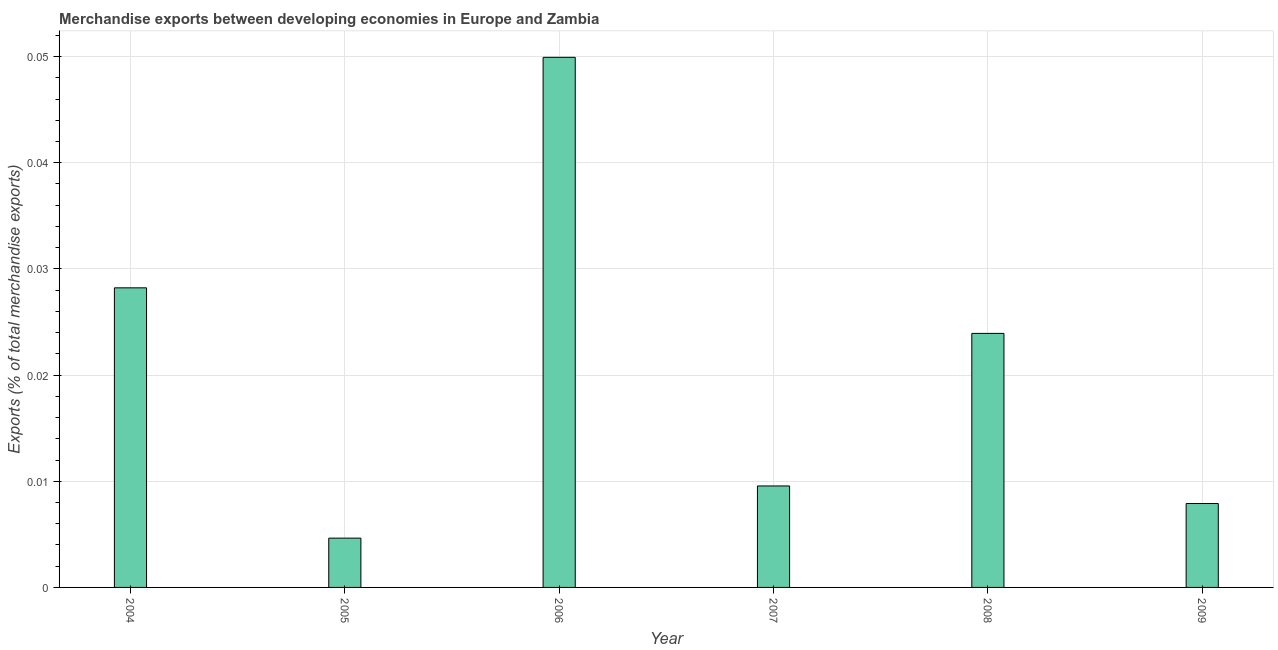Does the graph contain any zero values?
Give a very brief answer. No. Does the graph contain grids?
Ensure brevity in your answer.  Yes. What is the title of the graph?
Make the answer very short. Merchandise exports between developing economies in Europe and Zambia. What is the label or title of the X-axis?
Make the answer very short. Year. What is the label or title of the Y-axis?
Offer a very short reply. Exports (% of total merchandise exports). What is the merchandise exports in 2006?
Offer a terse response. 0.05. Across all years, what is the maximum merchandise exports?
Give a very brief answer. 0.05. Across all years, what is the minimum merchandise exports?
Give a very brief answer. 0. In which year was the merchandise exports maximum?
Your answer should be compact. 2006. What is the sum of the merchandise exports?
Your answer should be very brief. 0.12. What is the difference between the merchandise exports in 2005 and 2007?
Offer a terse response. -0.01. What is the average merchandise exports per year?
Offer a very short reply. 0.02. What is the median merchandise exports?
Keep it short and to the point. 0.02. In how many years, is the merchandise exports greater than 0.044 %?
Your answer should be very brief. 1. What is the ratio of the merchandise exports in 2004 to that in 2009?
Ensure brevity in your answer.  3.57. What is the difference between the highest and the second highest merchandise exports?
Your answer should be very brief. 0.02. Is the sum of the merchandise exports in 2008 and 2009 greater than the maximum merchandise exports across all years?
Provide a succinct answer. No. What is the difference between the highest and the lowest merchandise exports?
Keep it short and to the point. 0.05. What is the difference between two consecutive major ticks on the Y-axis?
Ensure brevity in your answer.  0.01. Are the values on the major ticks of Y-axis written in scientific E-notation?
Provide a succinct answer. No. What is the Exports (% of total merchandise exports) of 2004?
Provide a short and direct response. 0.03. What is the Exports (% of total merchandise exports) in 2005?
Provide a short and direct response. 0. What is the Exports (% of total merchandise exports) in 2006?
Make the answer very short. 0.05. What is the Exports (% of total merchandise exports) of 2007?
Offer a very short reply. 0.01. What is the Exports (% of total merchandise exports) of 2008?
Provide a short and direct response. 0.02. What is the Exports (% of total merchandise exports) in 2009?
Make the answer very short. 0.01. What is the difference between the Exports (% of total merchandise exports) in 2004 and 2005?
Offer a very short reply. 0.02. What is the difference between the Exports (% of total merchandise exports) in 2004 and 2006?
Your response must be concise. -0.02. What is the difference between the Exports (% of total merchandise exports) in 2004 and 2007?
Make the answer very short. 0.02. What is the difference between the Exports (% of total merchandise exports) in 2004 and 2008?
Keep it short and to the point. 0. What is the difference between the Exports (% of total merchandise exports) in 2004 and 2009?
Offer a terse response. 0.02. What is the difference between the Exports (% of total merchandise exports) in 2005 and 2006?
Your answer should be very brief. -0.05. What is the difference between the Exports (% of total merchandise exports) in 2005 and 2007?
Give a very brief answer. -0. What is the difference between the Exports (% of total merchandise exports) in 2005 and 2008?
Your response must be concise. -0.02. What is the difference between the Exports (% of total merchandise exports) in 2005 and 2009?
Your answer should be compact. -0. What is the difference between the Exports (% of total merchandise exports) in 2006 and 2007?
Your answer should be very brief. 0.04. What is the difference between the Exports (% of total merchandise exports) in 2006 and 2008?
Your answer should be compact. 0.03. What is the difference between the Exports (% of total merchandise exports) in 2006 and 2009?
Your response must be concise. 0.04. What is the difference between the Exports (% of total merchandise exports) in 2007 and 2008?
Provide a succinct answer. -0.01. What is the difference between the Exports (% of total merchandise exports) in 2007 and 2009?
Keep it short and to the point. 0. What is the difference between the Exports (% of total merchandise exports) in 2008 and 2009?
Give a very brief answer. 0.02. What is the ratio of the Exports (% of total merchandise exports) in 2004 to that in 2005?
Your response must be concise. 6.08. What is the ratio of the Exports (% of total merchandise exports) in 2004 to that in 2006?
Provide a succinct answer. 0.56. What is the ratio of the Exports (% of total merchandise exports) in 2004 to that in 2007?
Your answer should be compact. 2.95. What is the ratio of the Exports (% of total merchandise exports) in 2004 to that in 2008?
Ensure brevity in your answer.  1.18. What is the ratio of the Exports (% of total merchandise exports) in 2004 to that in 2009?
Provide a short and direct response. 3.57. What is the ratio of the Exports (% of total merchandise exports) in 2005 to that in 2006?
Provide a succinct answer. 0.09. What is the ratio of the Exports (% of total merchandise exports) in 2005 to that in 2007?
Ensure brevity in your answer.  0.49. What is the ratio of the Exports (% of total merchandise exports) in 2005 to that in 2008?
Offer a very short reply. 0.19. What is the ratio of the Exports (% of total merchandise exports) in 2005 to that in 2009?
Your answer should be compact. 0.59. What is the ratio of the Exports (% of total merchandise exports) in 2006 to that in 2007?
Keep it short and to the point. 5.22. What is the ratio of the Exports (% of total merchandise exports) in 2006 to that in 2008?
Your response must be concise. 2.09. What is the ratio of the Exports (% of total merchandise exports) in 2006 to that in 2009?
Give a very brief answer. 6.32. What is the ratio of the Exports (% of total merchandise exports) in 2007 to that in 2008?
Provide a succinct answer. 0.4. What is the ratio of the Exports (% of total merchandise exports) in 2007 to that in 2009?
Your answer should be very brief. 1.21. What is the ratio of the Exports (% of total merchandise exports) in 2008 to that in 2009?
Your answer should be very brief. 3.03. 